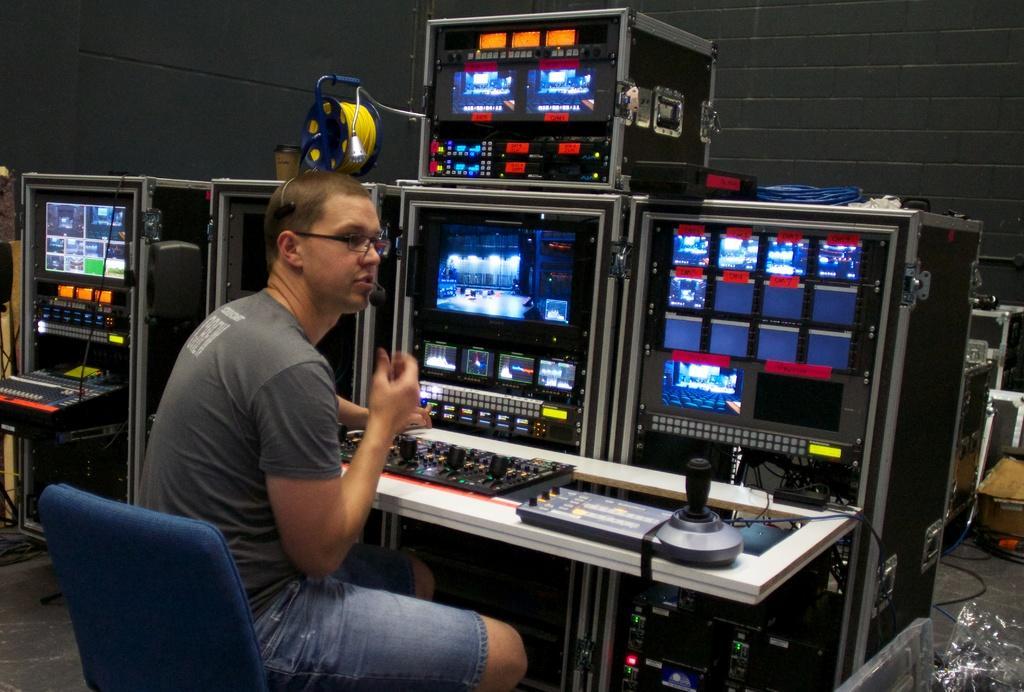Could you give a brief overview of what you see in this image? In the center of the image a person sitting on the chair at the editing equipment. In the background there is a wall. 